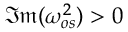<formula> <loc_0><loc_0><loc_500><loc_500>\mathfrak { I m } ( \omega _ { o s } ^ { 2 } ) > 0</formula> 